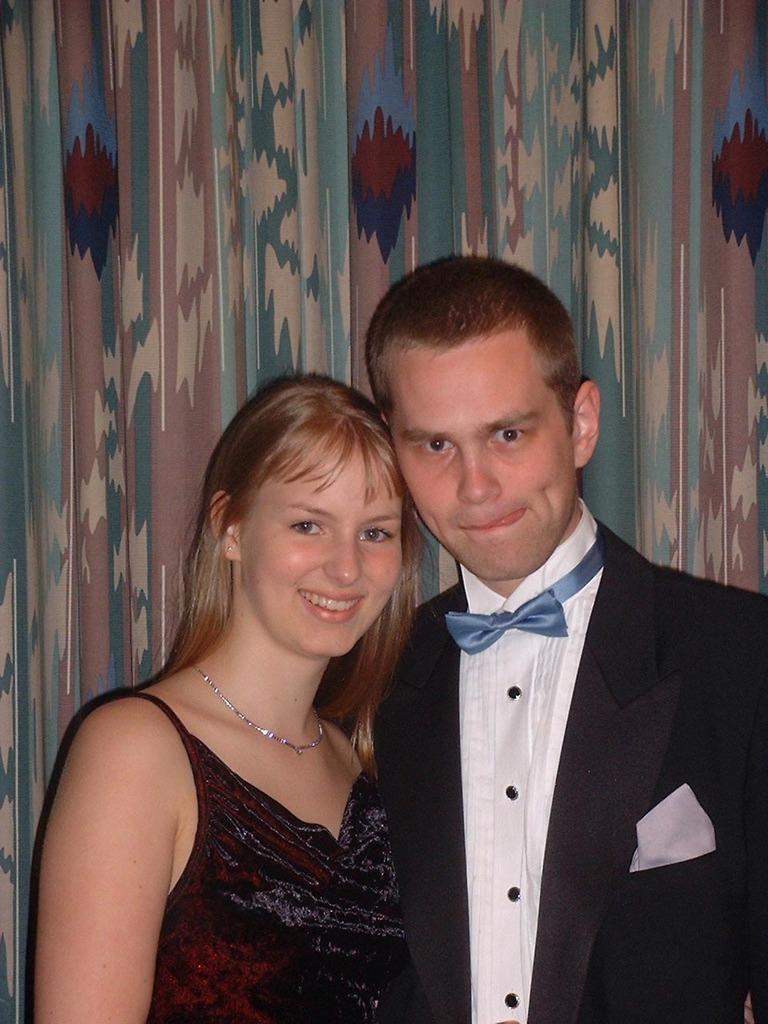How many people are in the image? There are two people in the image. Can you describe one of the people in the image? One of the people is a woman. What is the woman doing in the image? The woman is smiling. What can be seen in the background of the image? There is a wall visible in the background of the image. How far away is the church from the people in the image? There is no church visible in the image, so it is not possible to determine the distance between the people and a church. 